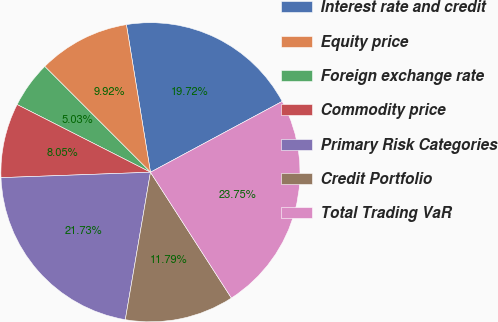Convert chart. <chart><loc_0><loc_0><loc_500><loc_500><pie_chart><fcel>Interest rate and credit<fcel>Equity price<fcel>Foreign exchange rate<fcel>Commodity price<fcel>Primary Risk Categories<fcel>Credit Portfolio<fcel>Total Trading VaR<nl><fcel>19.72%<fcel>9.92%<fcel>5.03%<fcel>8.05%<fcel>21.73%<fcel>11.79%<fcel>23.75%<nl></chart> 